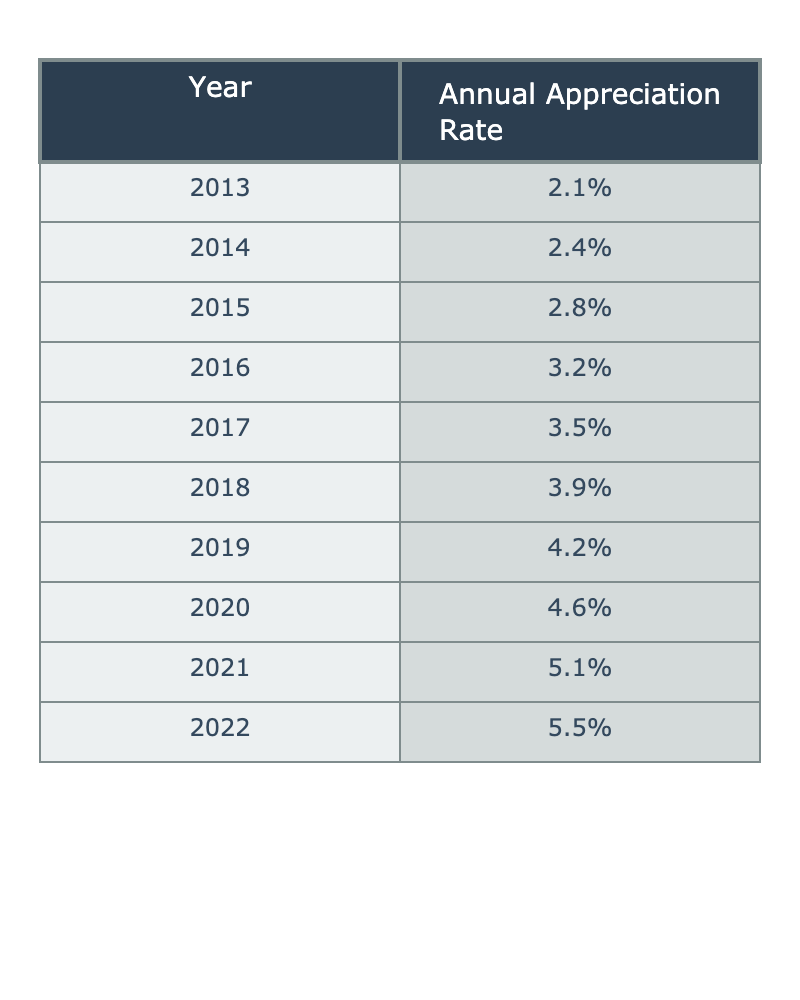What was the annual appreciation rate in 2015? According to the table, the annual appreciation rate for the year 2015 is directly listed as 2.8%.
Answer: 2.8% What is the highest annual appreciation rate recorded in the last decade? By looking through the table, the highest rate listed is for the year 2022, which is 5.5%.
Answer: 5.5% What was the average annual appreciation rate from 2013 to 2022? To find the average, we sum the appreciation rates: (2.1 + 2.4 + 2.8 + 3.2 + 3.5 + 3.9 + 4.2 + 4.6 + 5.1 + 5.5) = 33.3%. There are 10 years, so the average is 33.3 / 10 = 3.33%.
Answer: 3.33% Has the annual appreciation rate ever decreased from one year to the next over the last decade? Looking at the table, all listed appreciation rates show an increasing trend each year without any decreases. Therefore, the answer is no.
Answer: No What was the percentage increase in the annual appreciation rate from 2019 to 2021? The appreciation rate in 2019 was 4.2% and in 2021 was 5.1%. The increase is calculated by: (5.1 - 4.2) = 0.9%.
Answer: 0.9% Which year saw the most significant increase in the annual appreciation rate compared to the previous year? By reviewing the table, the largest increase occurred from 2021 to 2022, where the rate went from 5.1% to 5.5%, an increase of 0.4%.
Answer: 0.4% What was the change in appreciation rate from 2016 to 2018? The appreciation rate in 2016 was 3.2% and in 2018 was 3.9%. The change is calculated as (3.9 - 3.2) = 0.7%.
Answer: 0.7% Was there an annual appreciation rate of 4.0% in the last decade? Reviewing the table, there is no year listed with an appreciation rate exactly at 4.0%; the closest rates are 3.9% (2018) and 4.2% (2019). Thus, the answer is no.
Answer: No What is the total appreciation rate increase over the last decade? The appreciation rate started at 2.1% in 2013 and reached 5.5% in 2022. Therefore, the total increase is (5.5 - 2.1) = 3.4%.
Answer: 3.4% 